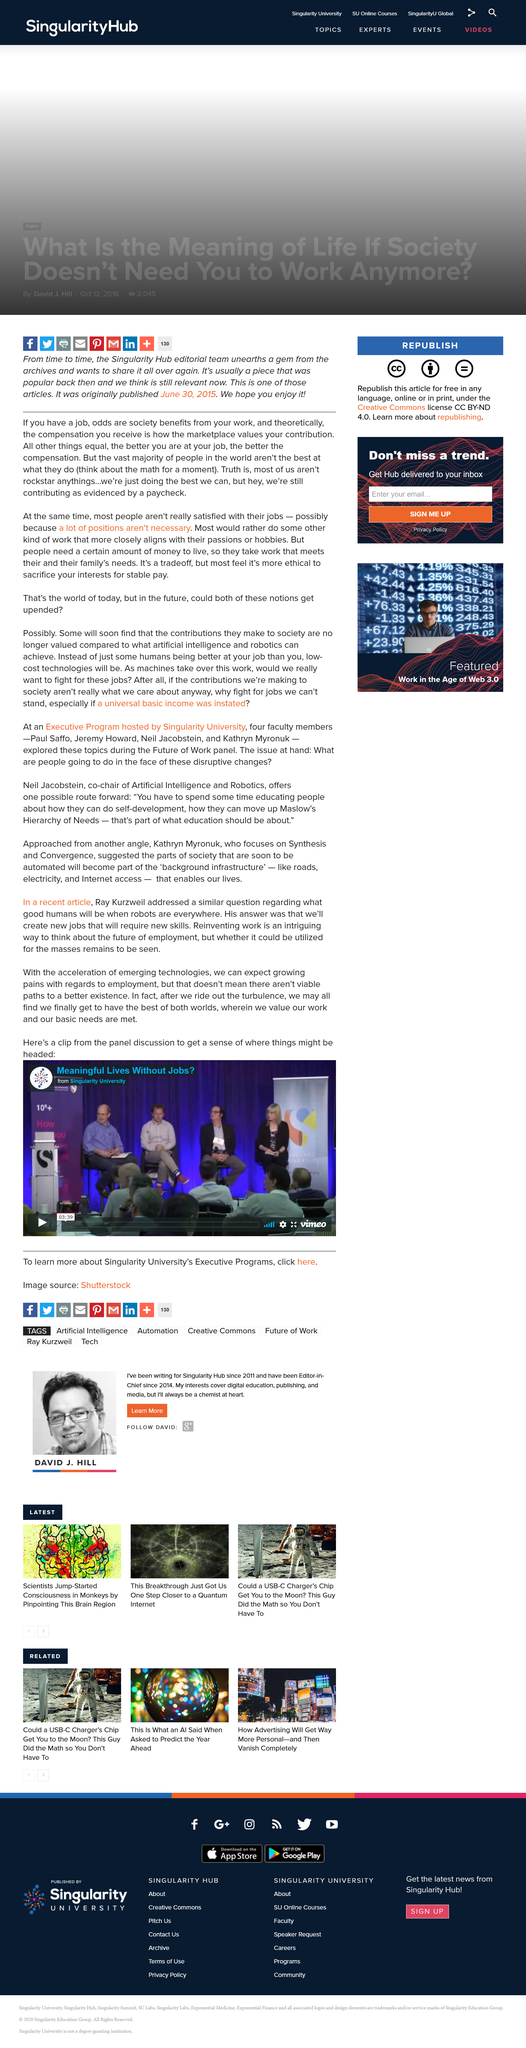Identify some key points in this picture. Kathryn Myronuk is dedicated to the fields of Synthesis and Convergence. The discussion panel is being held at Singularity University. Ray Kurzweil predicts that there will be growing pains in the job market as new jobs are created that require new skills, leading to a shift in the types of workers needed. 